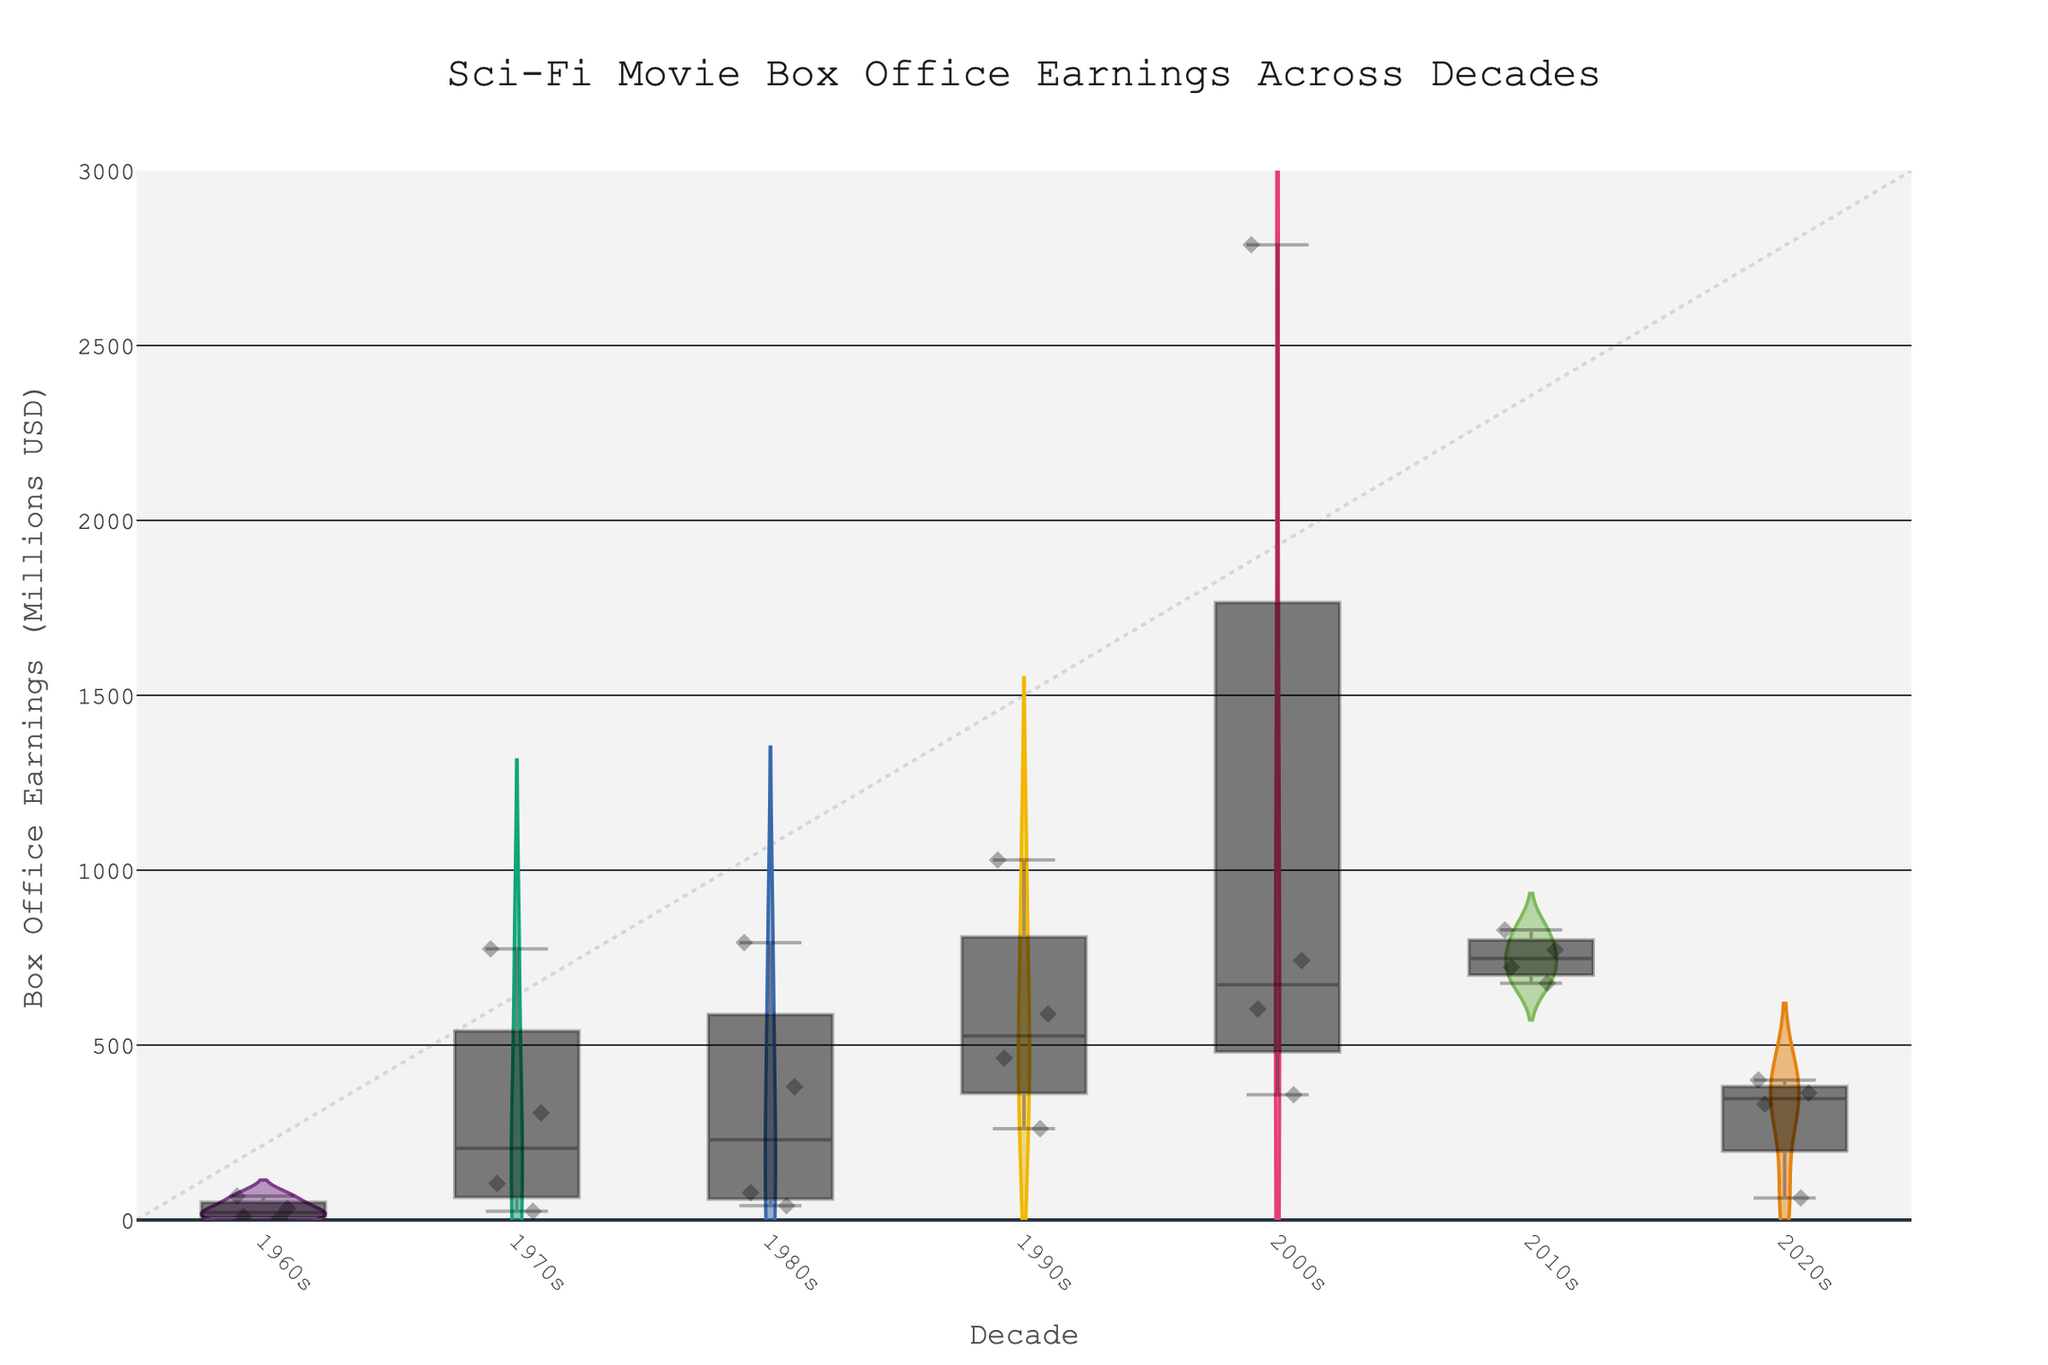what is the title of the plot? The title of the plot is displayed at the top and is clear to see. It reads "Sci-Fi Movie Box Office Earnings Across Decades".
Answer: Sci-Fi Movie Box Office Earnings Across Decades Which decade has the movie with the highest box office earnings? The decade with the movie that has the highest box office earnings can be identified by looking for the tallest violin plot on the Y-axis. The tallest is in the 2000s. The movie "Avatar" has box office earnings of 2788 million USD.
Answer: 2000s How does the average box office earnings of the 1960s compare to the 2010s? First, estimate the center or median of the violin plots for both decades by eye. The 1960s plot seems to center around lower earnings compared to the 2010s. Exact calculation isn't possible on a plot but visually, the 2010s have higher average earnings.
Answer: 2010s higher What is the range of box office earnings for the movies in the 1980s? The range is determined by the highest and lowest points of the violin plot for the 1980s. The lowest point looks around 41 million USD (Blade Runner) and the highest point around 793 million USD (E.T. the Extra-Terrestrial).
Answer: 41 to 793 million USD Which decade has more variation in box office earnings, 1970s or 1990s? Variation can be inferred from the spread of the violin plot. The 1990s have a wider spread from around 261 million USD to over 1029 million USD compared to the 1970s which ranges from around 25 million USD to 775 million USD.
Answer: 1990s Are there any outliers noticeable in the plot? Outliers are points that significantly stand out from the rest. There are several possible outliers: "2001: A Space Odyssey" in the 1960s, "E.T." in the 1980s, and "Avatar" in the 2000s have far higher earnings than other movies within their decades.
Answer: Yes What movie from the 2020s has the highest box office earnings? By inspecting the jittered points within the 2020s violin plot, "Free Guy" stands out with the highest earnings of 331 million USD.
Answer: Free Guy Which decade has the least number of movies in the chart? Count the jittered points within each violin plot. The 1960s have the least number of movies, with only four points.
Answer: 1960s 